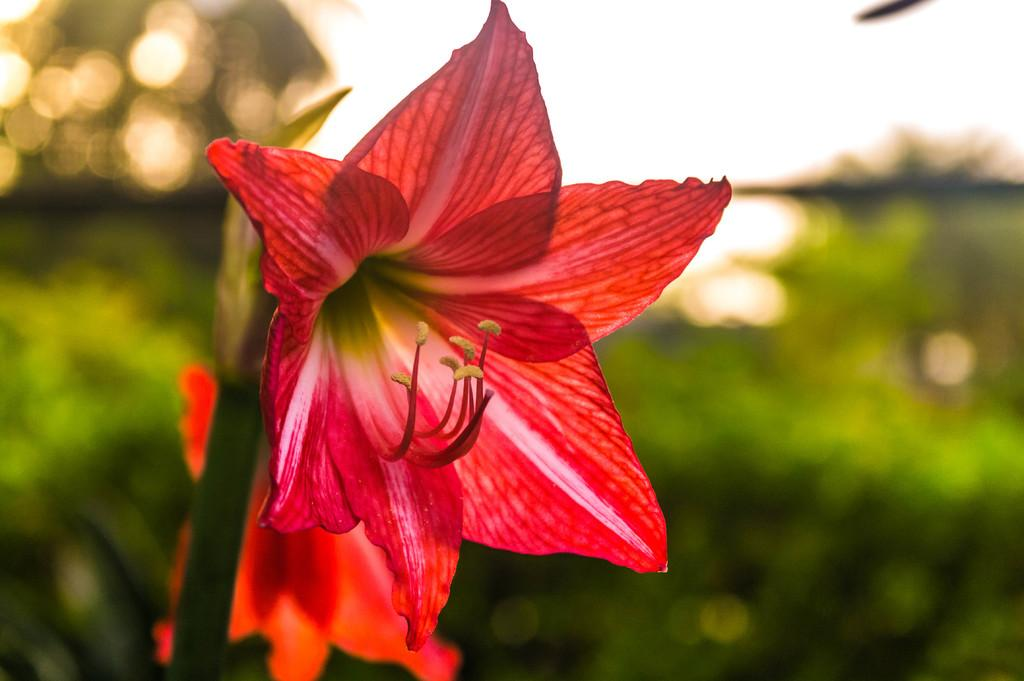What is present in the picture? There is a plant in the picture. How many flowers does the plant have? The plant has two flowers. Can you describe the background of the image? The background of the image is blurred. What type of pump is visible in the background of the image? There is no pump present in the image; the background is blurred. 